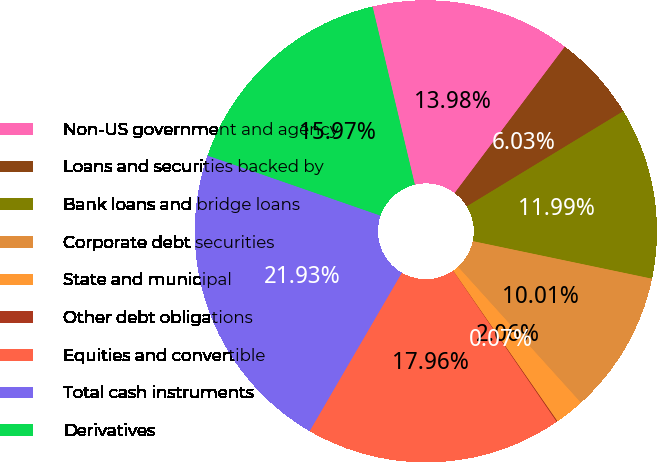Convert chart to OTSL. <chart><loc_0><loc_0><loc_500><loc_500><pie_chart><fcel>Non-US government and agency<fcel>Loans and securities backed by<fcel>Bank loans and bridge loans<fcel>Corporate debt securities<fcel>State and municipal<fcel>Other debt obligations<fcel>Equities and convertible<fcel>Total cash instruments<fcel>Derivatives<nl><fcel>13.98%<fcel>6.03%<fcel>11.99%<fcel>10.01%<fcel>2.06%<fcel>0.07%<fcel>17.96%<fcel>21.93%<fcel>15.97%<nl></chart> 